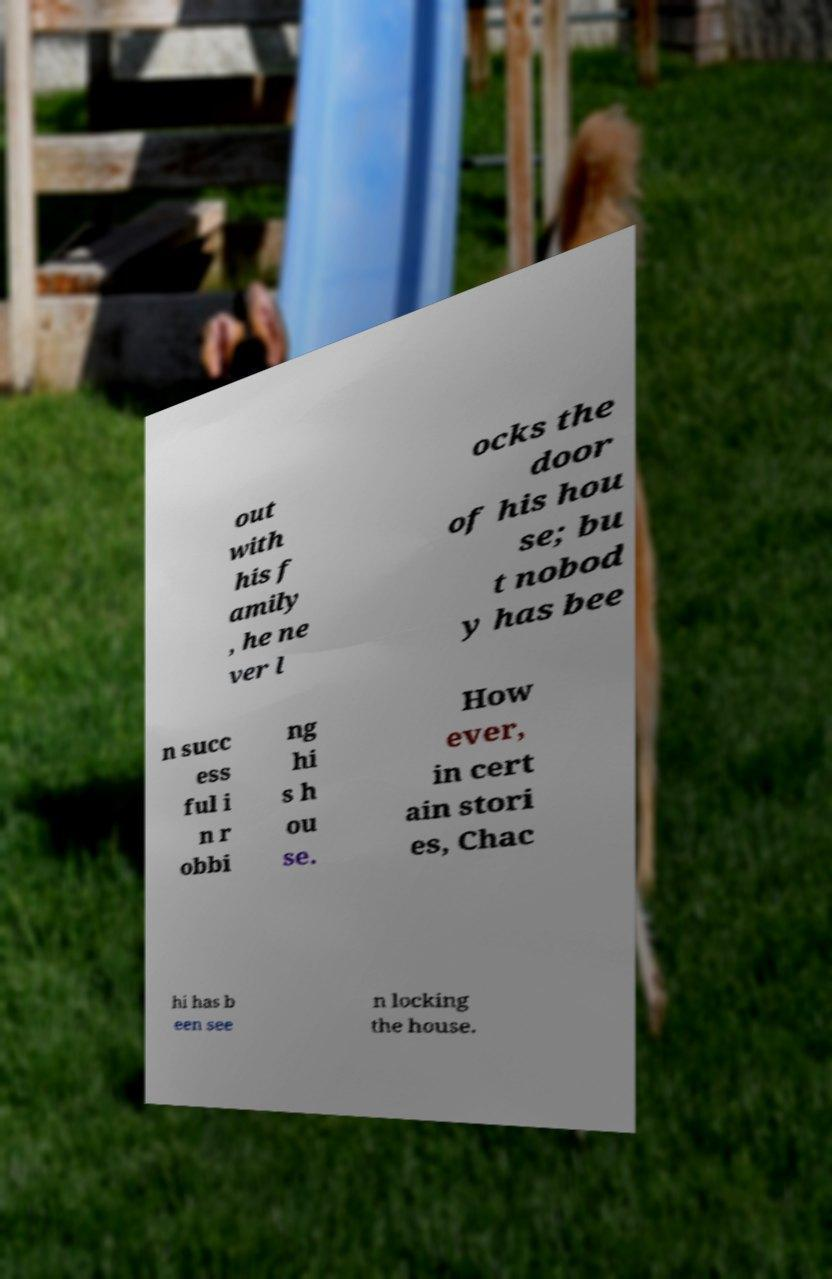Please read and relay the text visible in this image. What does it say? out with his f amily , he ne ver l ocks the door of his hou se; bu t nobod y has bee n succ ess ful i n r obbi ng hi s h ou se. How ever, in cert ain stori es, Chac hi has b een see n locking the house. 